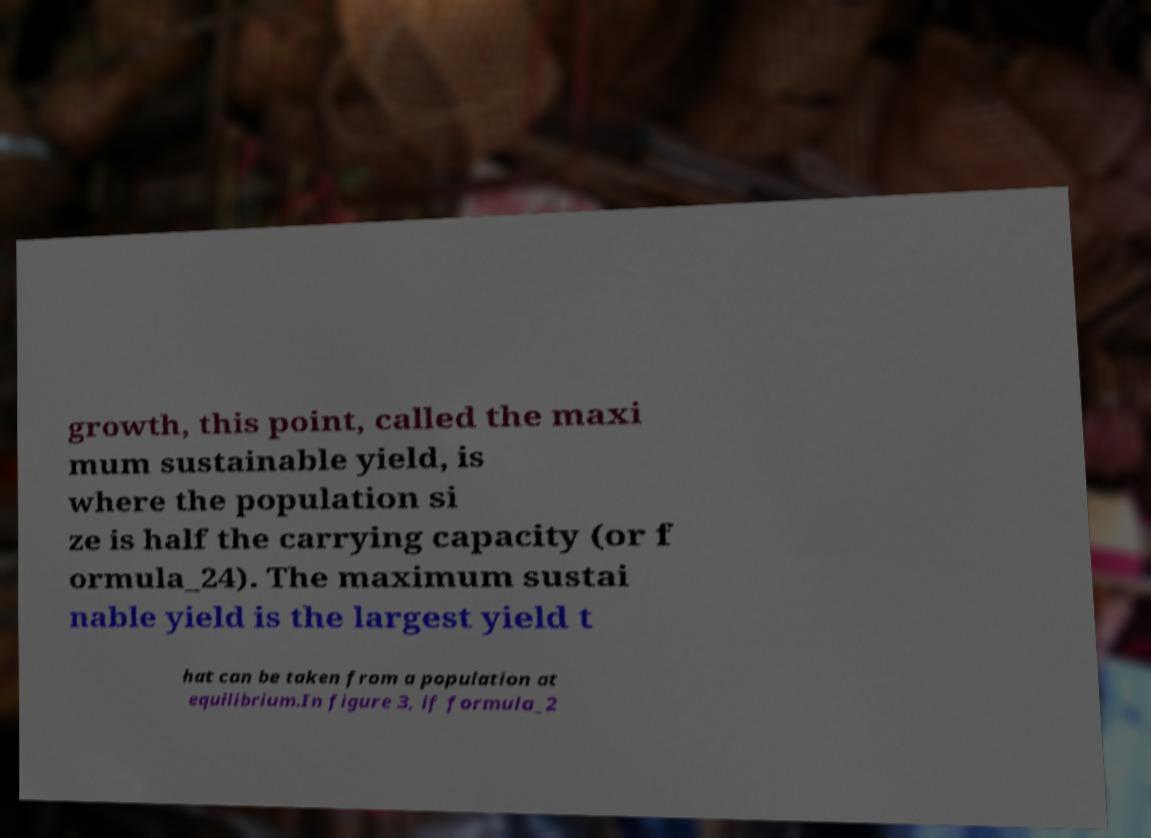I need the written content from this picture converted into text. Can you do that? growth, this point, called the maxi mum sustainable yield, is where the population si ze is half the carrying capacity (or f ormula_24). The maximum sustai nable yield is the largest yield t hat can be taken from a population at equilibrium.In figure 3, if formula_2 